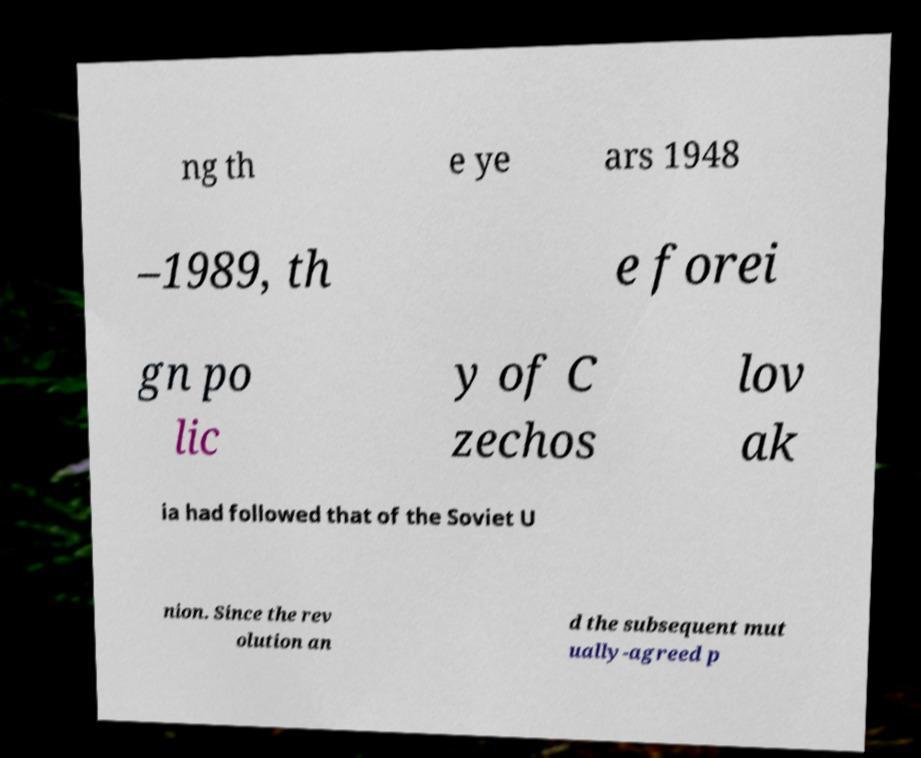What messages or text are displayed in this image? I need them in a readable, typed format. ng th e ye ars 1948 –1989, th e forei gn po lic y of C zechos lov ak ia had followed that of the Soviet U nion. Since the rev olution an d the subsequent mut ually-agreed p 